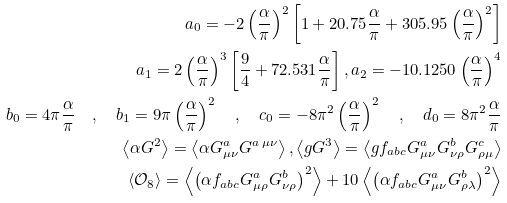Convert formula to latex. <formula><loc_0><loc_0><loc_500><loc_500>a _ { 0 } = - 2 \left ( \frac { \alpha } { \pi } \right ) ^ { 2 } \left [ 1 + 2 0 . 7 5 \frac { \alpha } { \pi } + 3 0 5 . 9 5 \left ( \frac { \alpha } { \pi } \right ) ^ { 2 } \right ] \\ a _ { 1 } = 2 \left ( \frac { \alpha } { \pi } \right ) ^ { 3 } \left [ \frac { 9 } { 4 } + 7 2 . 5 3 1 \frac { \alpha } { \pi } \right ] , a _ { 2 } = - 1 0 . 1 2 5 0 \left ( \frac { \alpha } { \pi } \right ) ^ { 4 } \\ b _ { 0 } = 4 \pi \frac { \alpha } { \pi } \quad , \quad b _ { 1 } = 9 \pi \left ( \frac { \alpha } { \pi } \right ) ^ { 2 } \quad , \quad c _ { 0 } = - 8 \pi ^ { 2 } \left ( \frac { \alpha } { \pi } \right ) ^ { 2 } \quad , \quad d _ { 0 } = 8 \pi ^ { 2 } \frac { \alpha } { \pi } \\ \left \langle \alpha G ^ { 2 } \right \rangle = \left \langle \alpha G ^ { a } _ { \mu \nu } G ^ { a \, \mu \nu } \right \rangle , \left \langle g G ^ { 3 } \right \rangle = \left \langle g f _ { a b c } G ^ { a } _ { \mu \nu } G ^ { b } _ { \nu \rho } G ^ { c } _ { \rho \mu } \right \rangle \\ \left \langle { \mathcal { O } } _ { 8 } \right \rangle = \left \langle \left ( \alpha f _ { a b c } G ^ { a } _ { \mu \rho } G ^ { b } _ { \nu \rho } \right ) ^ { 2 } \right \rangle + 1 0 \left \langle \left ( \alpha f _ { a b c } G ^ { a } _ { \mu \nu } G ^ { b } _ { \rho \lambda } \right ) ^ { 2 } \right \rangle</formula> 